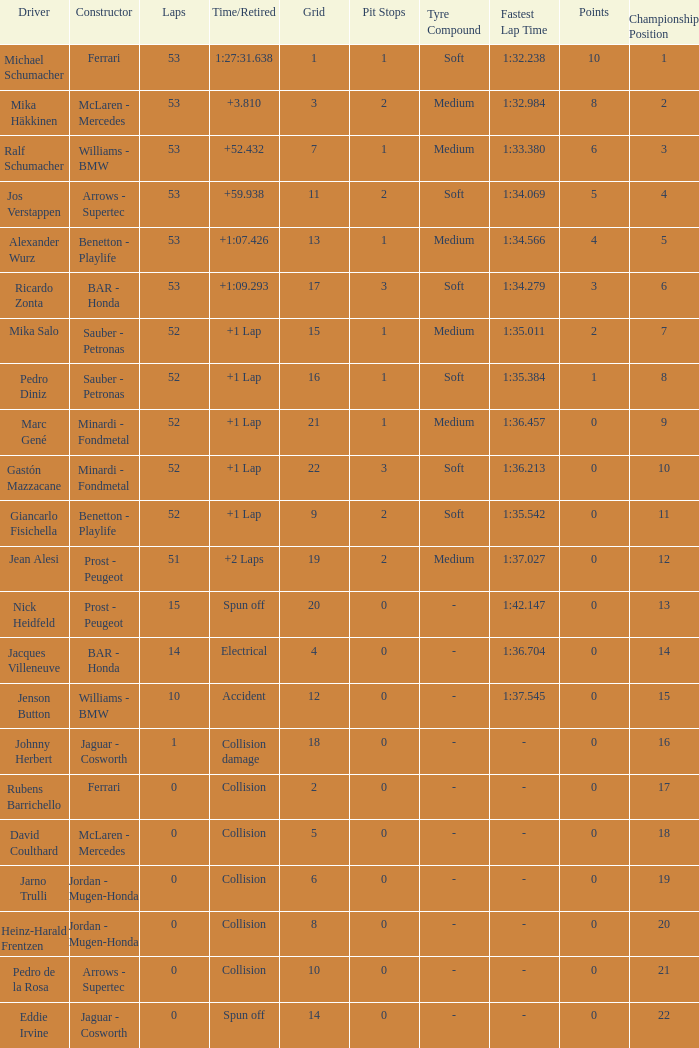How many laps did Ricardo Zonta have? 53.0. 